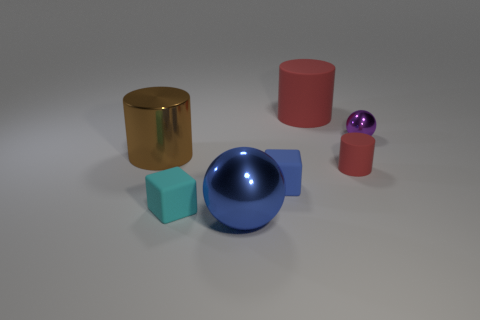Do the small blue rubber thing and the blue shiny object have the same shape?
Provide a succinct answer. No. How many things are either red things in front of the metallic cylinder or small purple shiny balls?
Your answer should be very brief. 2. There is a large shiny object in front of the cylinder left of the big metallic thing that is in front of the brown cylinder; what is its shape?
Offer a very short reply. Sphere. There is a small thing that is made of the same material as the blue sphere; what is its shape?
Your response must be concise. Sphere. What size is the blue ball?
Your response must be concise. Large. Do the brown object and the blue ball have the same size?
Your answer should be compact. Yes. What number of things are either matte cylinders in front of the tiny purple sphere or metal things in front of the large brown cylinder?
Keep it short and to the point. 2. How many shiny balls are behind the ball on the left side of the rubber cylinder in front of the big brown thing?
Your response must be concise. 1. There is a object that is left of the cyan matte cube; what size is it?
Give a very brief answer. Large. What number of blue spheres are the same size as the brown cylinder?
Keep it short and to the point. 1. 